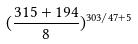<formula> <loc_0><loc_0><loc_500><loc_500>( \frac { 3 1 5 + 1 9 4 } { 8 } ) ^ { 3 0 3 / 4 7 + 5 }</formula> 